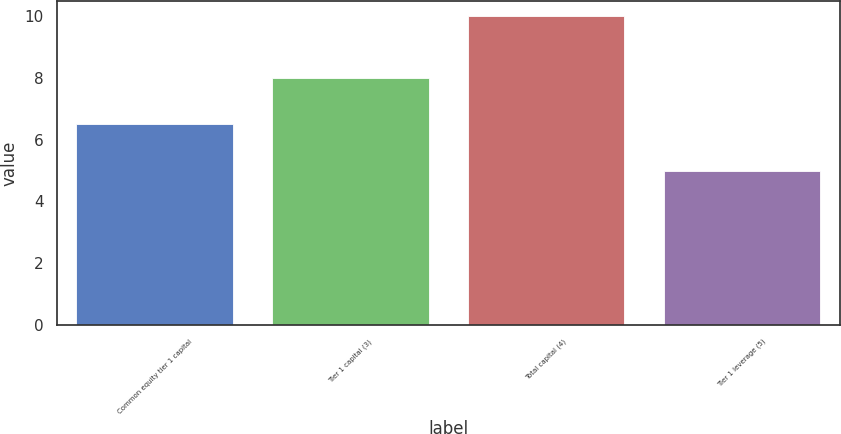<chart> <loc_0><loc_0><loc_500><loc_500><bar_chart><fcel>Common equity tier 1 capital<fcel>Tier 1 capital (3)<fcel>Total capital (4)<fcel>Tier 1 leverage (5)<nl><fcel>6.5<fcel>8<fcel>10<fcel>5<nl></chart> 